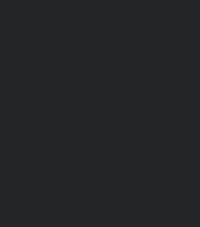Convert code to text. <code><loc_0><loc_0><loc_500><loc_500><_Lisp_>
</code> 